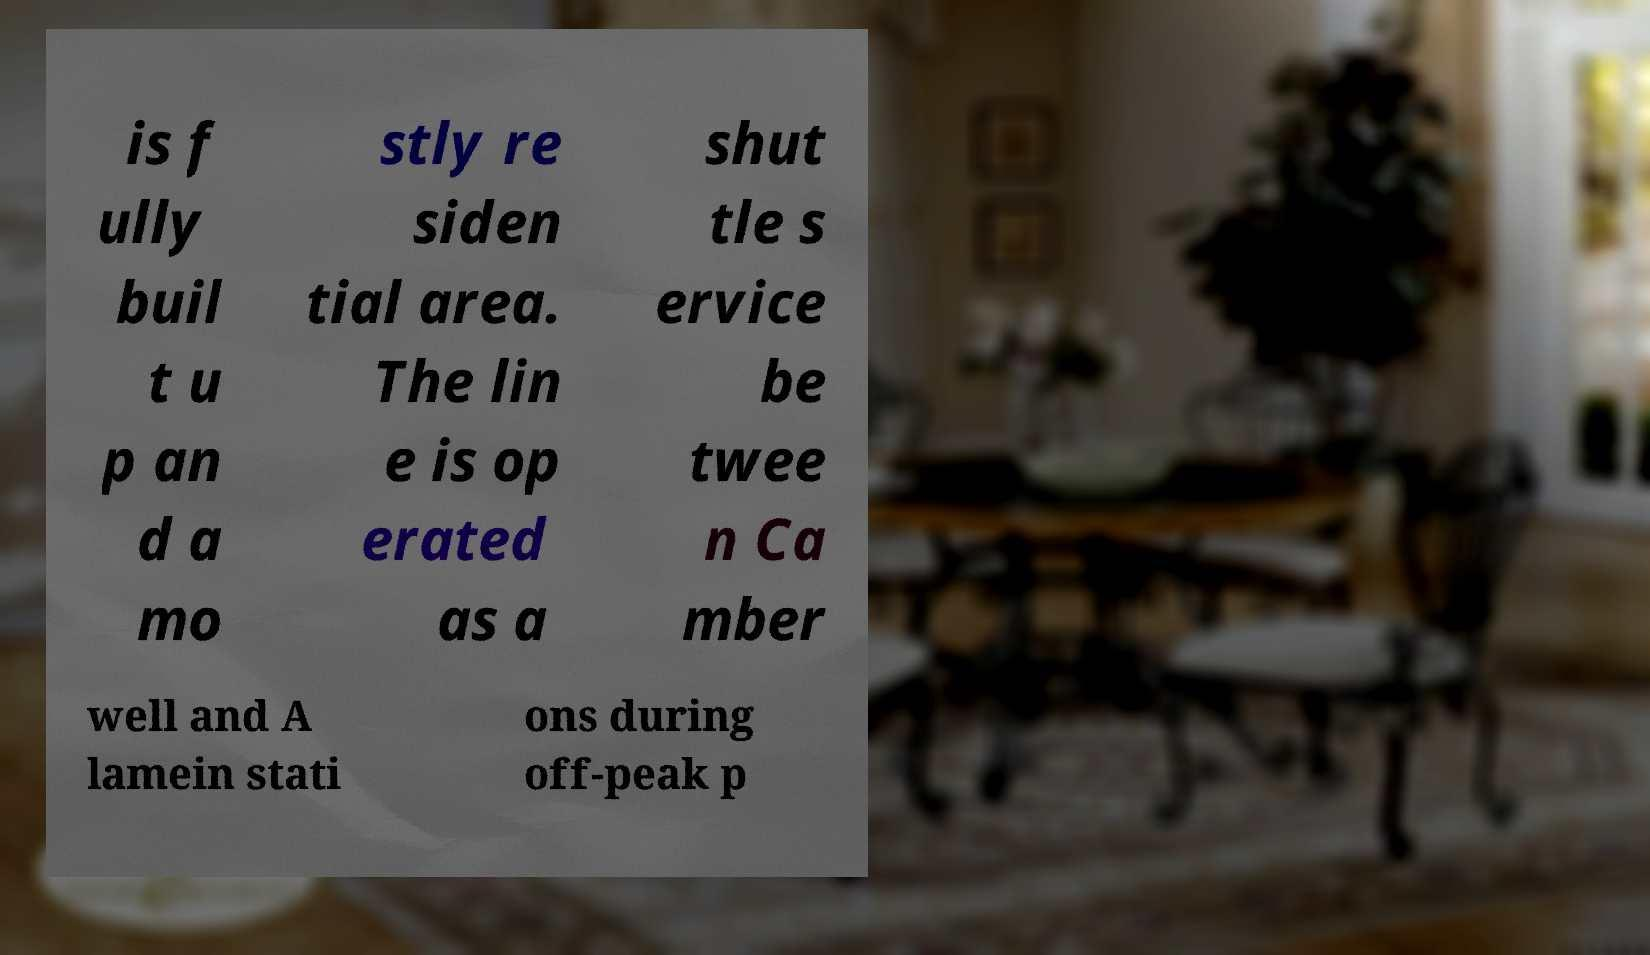Please identify and transcribe the text found in this image. is f ully buil t u p an d a mo stly re siden tial area. The lin e is op erated as a shut tle s ervice be twee n Ca mber well and A lamein stati ons during off-peak p 